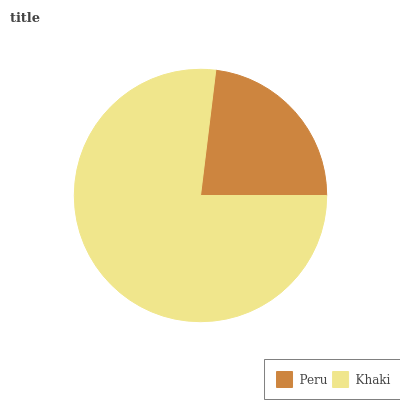Is Peru the minimum?
Answer yes or no. Yes. Is Khaki the maximum?
Answer yes or no. Yes. Is Khaki the minimum?
Answer yes or no. No. Is Khaki greater than Peru?
Answer yes or no. Yes. Is Peru less than Khaki?
Answer yes or no. Yes. Is Peru greater than Khaki?
Answer yes or no. No. Is Khaki less than Peru?
Answer yes or no. No. Is Khaki the high median?
Answer yes or no. Yes. Is Peru the low median?
Answer yes or no. Yes. Is Peru the high median?
Answer yes or no. No. Is Khaki the low median?
Answer yes or no. No. 